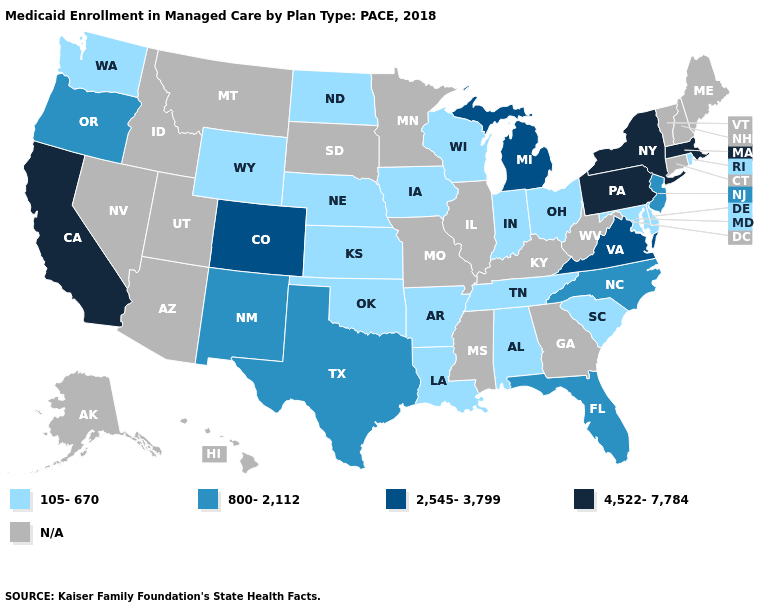What is the highest value in the Northeast ?
Be succinct. 4,522-7,784. Name the states that have a value in the range 800-2,112?
Short answer required. Florida, New Jersey, New Mexico, North Carolina, Oregon, Texas. Name the states that have a value in the range 2,545-3,799?
Write a very short answer. Colorado, Michigan, Virginia. Name the states that have a value in the range 4,522-7,784?
Write a very short answer. California, Massachusetts, New York, Pennsylvania. What is the highest value in the MidWest ?
Keep it brief. 2,545-3,799. Does Colorado have the lowest value in the USA?
Write a very short answer. No. How many symbols are there in the legend?
Short answer required. 5. Name the states that have a value in the range 2,545-3,799?
Short answer required. Colorado, Michigan, Virginia. Name the states that have a value in the range 2,545-3,799?
Be succinct. Colorado, Michigan, Virginia. What is the value of South Dakota?
Write a very short answer. N/A. Which states hav the highest value in the South?
Quick response, please. Virginia. What is the value of Rhode Island?
Be succinct. 105-670. Which states hav the highest value in the Northeast?
Give a very brief answer. Massachusetts, New York, Pennsylvania. Among the states that border Maryland , which have the lowest value?
Concise answer only. Delaware. What is the value of Tennessee?
Answer briefly. 105-670. 